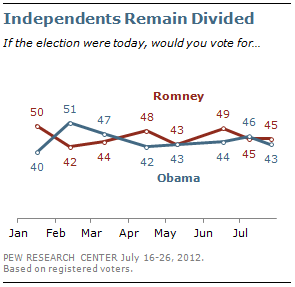Mention a couple of crucial points in this snapshot. In the chart, the red line represents Mitt Romney. The average of the last three months for President Obama is 44.3333... 